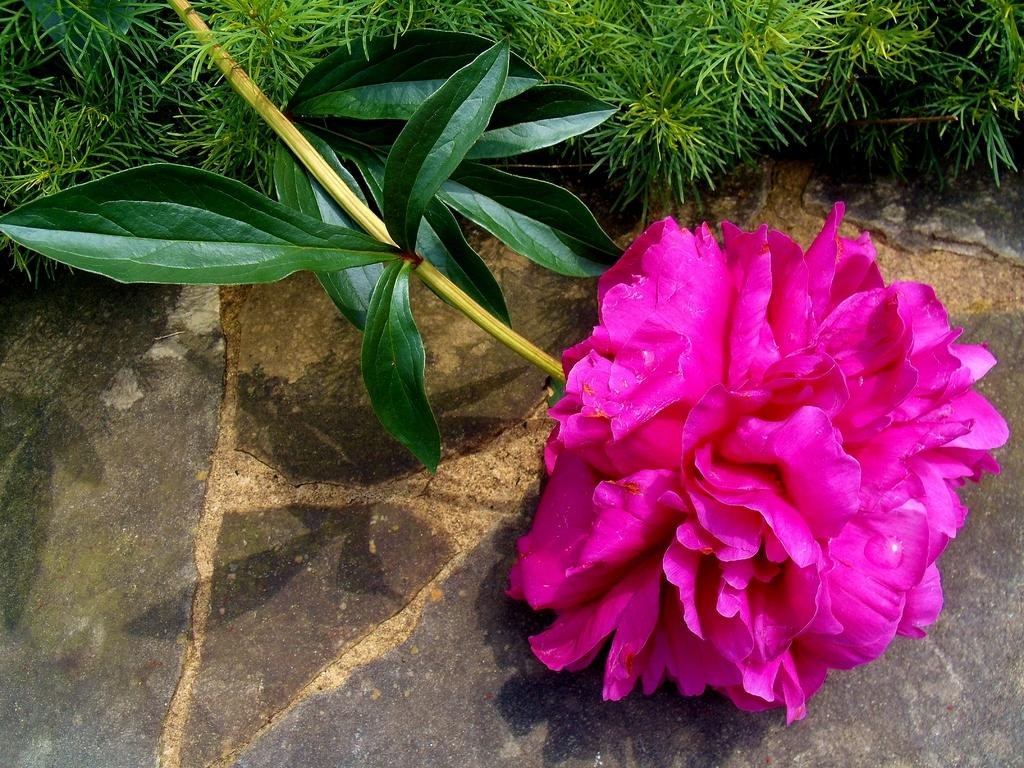What is the main subject in the center of the image? There is a flower with leaves in the center of the image. What type of vegetation can be seen in the background of the image? There is grass in the background of the image. What surface is visible at the bottom of the image? There is a floor visible at the bottom of the image. How many rings are visible on the flower in the image? There are no rings present on the flower in the image; it is a single flower with leaves. 